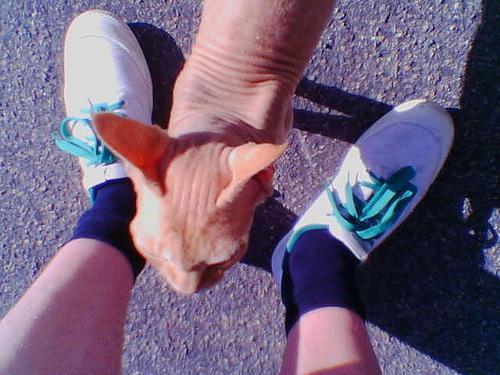How many people are there?
Give a very brief answer. 1. How many birds have red on their head?
Give a very brief answer. 0. 